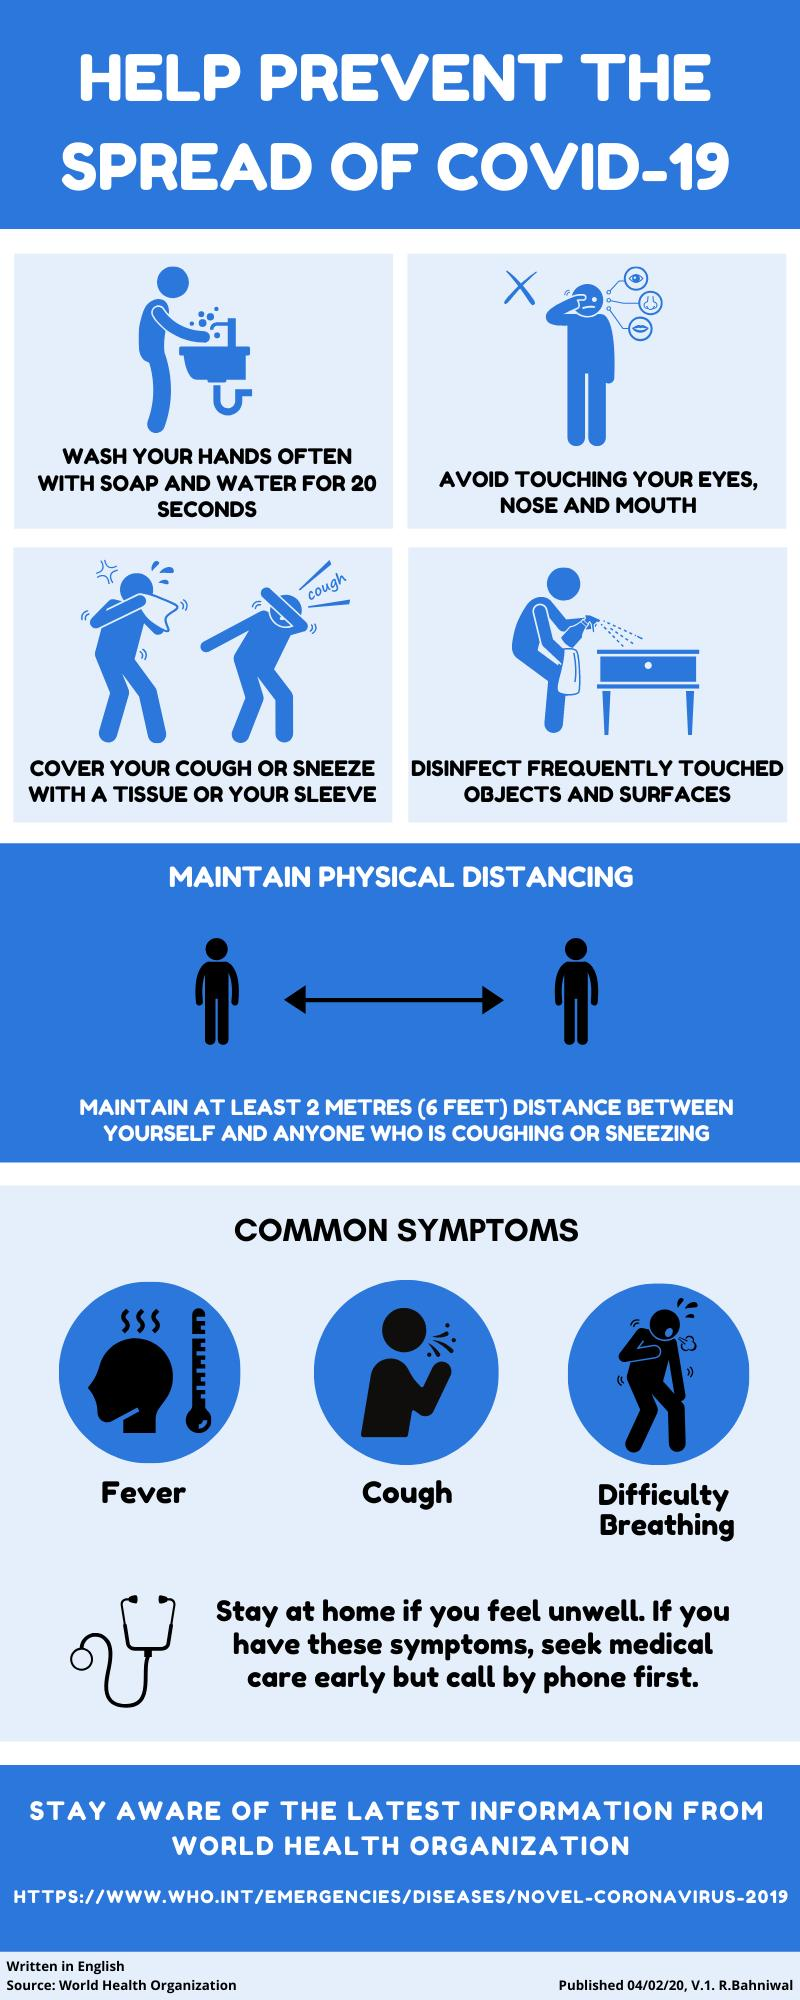Highlight a few significant elements in this photo. The common symptom of COVID-19, in addition to fever and cough, is difficulty breathing. It is recommended to wash one's hands for at least 20 seconds in order to effectively prevent the spread of COVID-19. 